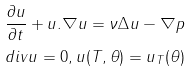<formula> <loc_0><loc_0><loc_500><loc_500>\frac { \partial u } { \partial t } + u . \nabla u = \nu \Delta u - \nabla p \\ d i v u = 0 , u ( T , \theta ) = u _ { T } ( \theta )</formula> 